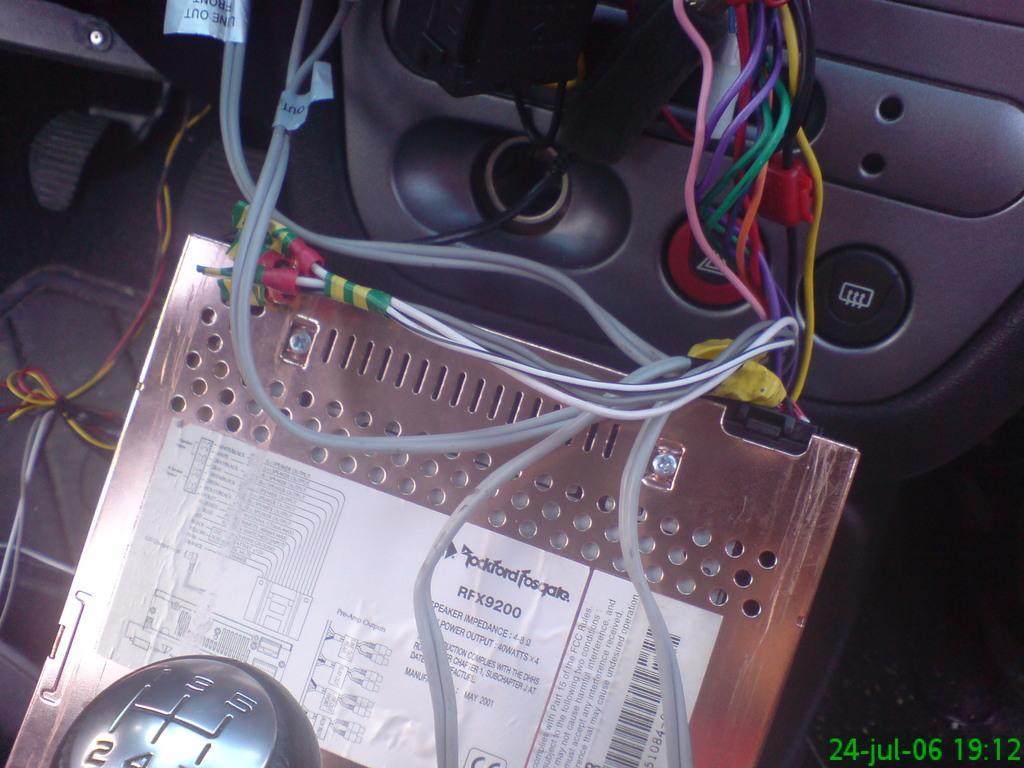Can you describe this image briefly? In this image I can see the interior of the vehicle in which I can see few wires, the gear rod and a metal object to which I can see a white colored sticker. 